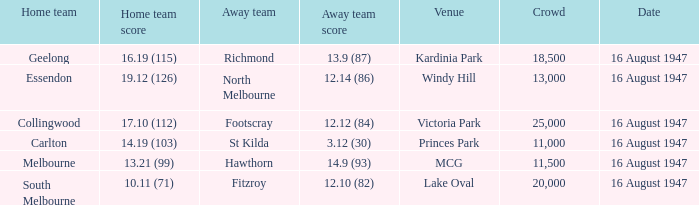What was the total score for the away team at victoria park? 12.12 (84). 